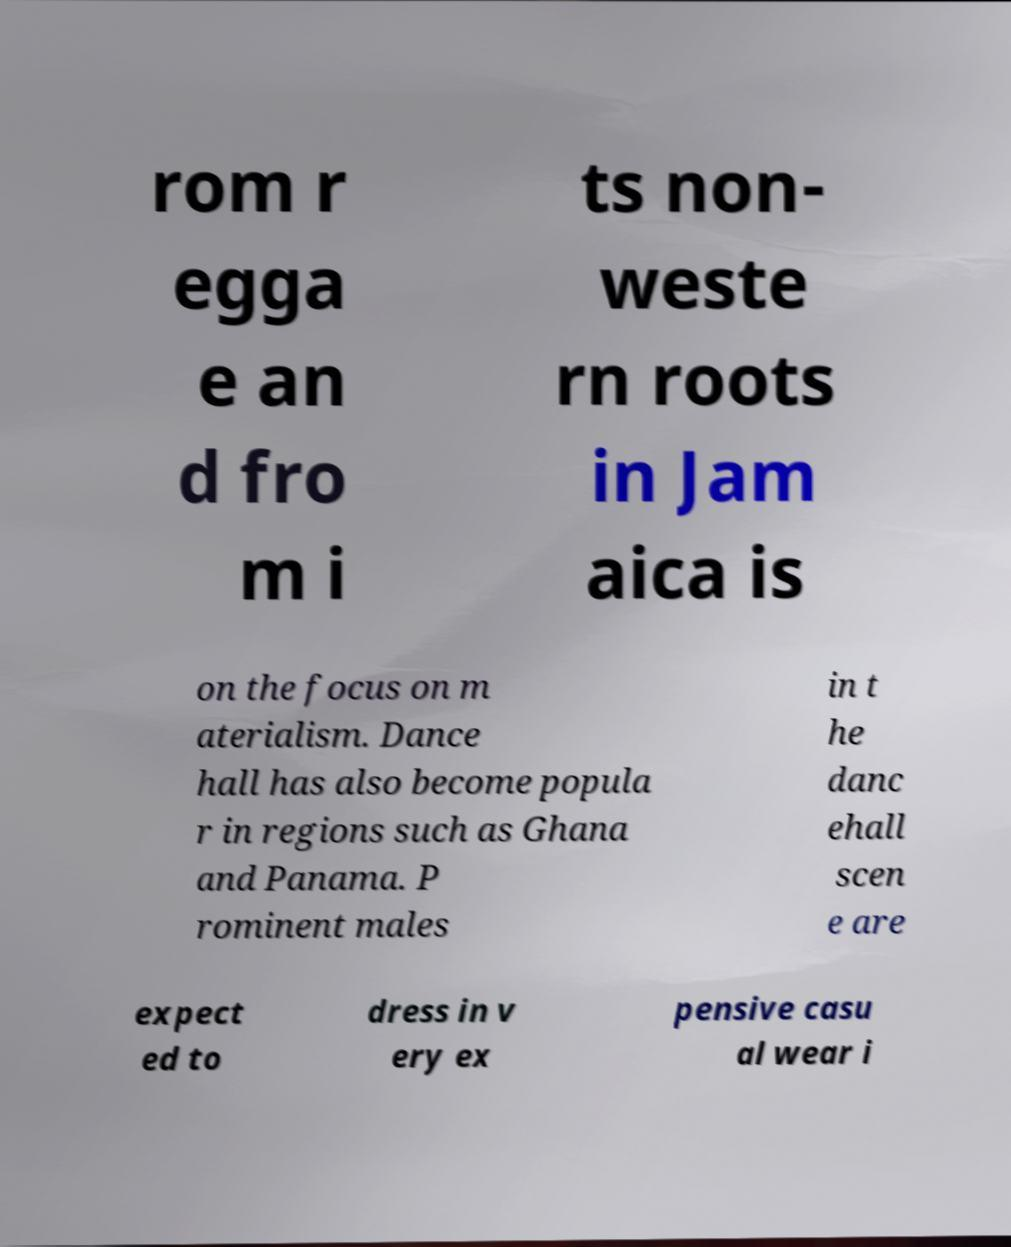What messages or text are displayed in this image? I need them in a readable, typed format. rom r egga e an d fro m i ts non- weste rn roots in Jam aica is on the focus on m aterialism. Dance hall has also become popula r in regions such as Ghana and Panama. P rominent males in t he danc ehall scen e are expect ed to dress in v ery ex pensive casu al wear i 